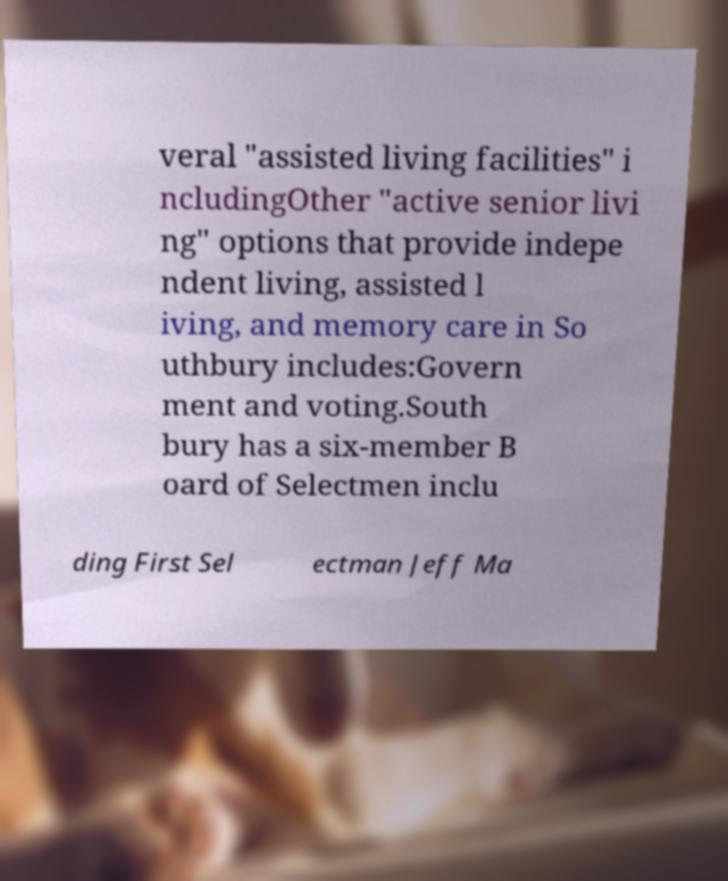Could you extract and type out the text from this image? veral "assisted living facilities" i ncludingOther "active senior livi ng" options that provide indepe ndent living, assisted l iving, and memory care in So uthbury includes:Govern ment and voting.South bury has a six-member B oard of Selectmen inclu ding First Sel ectman Jeff Ma 